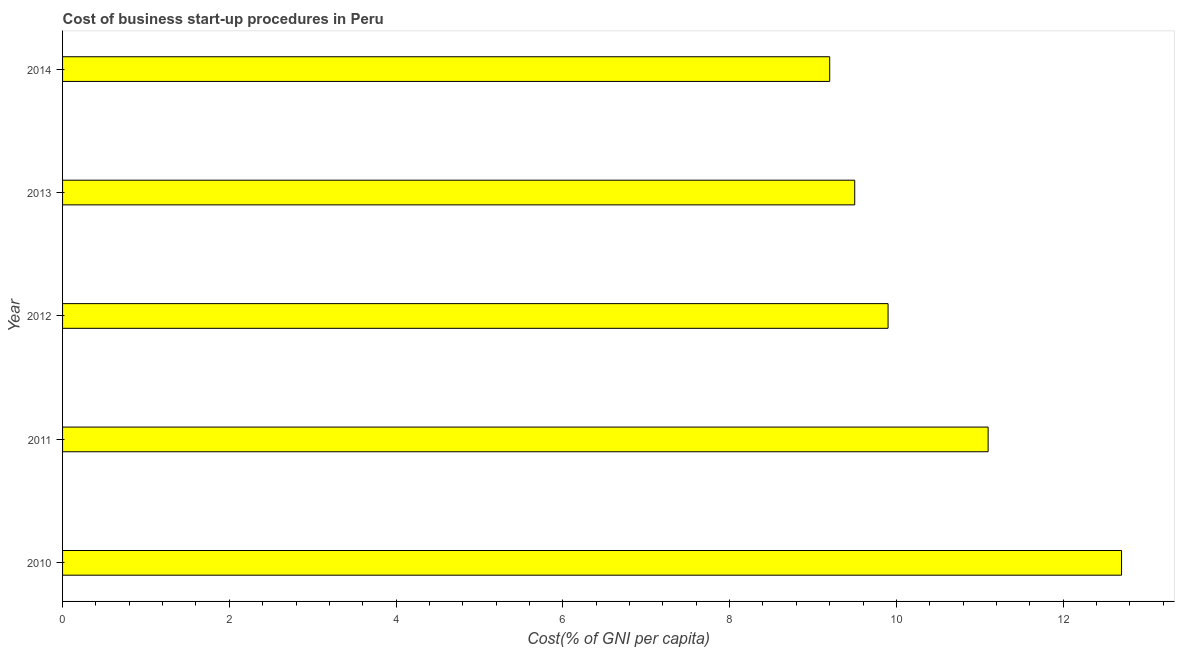Does the graph contain any zero values?
Provide a short and direct response. No. What is the title of the graph?
Your answer should be compact. Cost of business start-up procedures in Peru. What is the label or title of the X-axis?
Offer a very short reply. Cost(% of GNI per capita). What is the label or title of the Y-axis?
Offer a terse response. Year. What is the cost of business startup procedures in 2013?
Provide a short and direct response. 9.5. Across all years, what is the maximum cost of business startup procedures?
Provide a succinct answer. 12.7. What is the sum of the cost of business startup procedures?
Your response must be concise. 52.4. What is the average cost of business startup procedures per year?
Offer a terse response. 10.48. In how many years, is the cost of business startup procedures greater than 9.2 %?
Ensure brevity in your answer.  4. Do a majority of the years between 2011 and 2012 (inclusive) have cost of business startup procedures greater than 3.2 %?
Ensure brevity in your answer.  Yes. What is the ratio of the cost of business startup procedures in 2012 to that in 2014?
Offer a very short reply. 1.08. Is the cost of business startup procedures in 2010 less than that in 2014?
Your answer should be compact. No. Are the values on the major ticks of X-axis written in scientific E-notation?
Your answer should be compact. No. What is the Cost(% of GNI per capita) of 2012?
Make the answer very short. 9.9. What is the Cost(% of GNI per capita) of 2014?
Make the answer very short. 9.2. What is the difference between the Cost(% of GNI per capita) in 2010 and 2012?
Give a very brief answer. 2.8. What is the difference between the Cost(% of GNI per capita) in 2011 and 2012?
Give a very brief answer. 1.2. What is the difference between the Cost(% of GNI per capita) in 2011 and 2013?
Your answer should be very brief. 1.6. What is the difference between the Cost(% of GNI per capita) in 2011 and 2014?
Offer a very short reply. 1.9. What is the difference between the Cost(% of GNI per capita) in 2013 and 2014?
Make the answer very short. 0.3. What is the ratio of the Cost(% of GNI per capita) in 2010 to that in 2011?
Provide a succinct answer. 1.14. What is the ratio of the Cost(% of GNI per capita) in 2010 to that in 2012?
Offer a terse response. 1.28. What is the ratio of the Cost(% of GNI per capita) in 2010 to that in 2013?
Give a very brief answer. 1.34. What is the ratio of the Cost(% of GNI per capita) in 2010 to that in 2014?
Give a very brief answer. 1.38. What is the ratio of the Cost(% of GNI per capita) in 2011 to that in 2012?
Give a very brief answer. 1.12. What is the ratio of the Cost(% of GNI per capita) in 2011 to that in 2013?
Provide a succinct answer. 1.17. What is the ratio of the Cost(% of GNI per capita) in 2011 to that in 2014?
Your answer should be very brief. 1.21. What is the ratio of the Cost(% of GNI per capita) in 2012 to that in 2013?
Offer a very short reply. 1.04. What is the ratio of the Cost(% of GNI per capita) in 2012 to that in 2014?
Offer a terse response. 1.08. What is the ratio of the Cost(% of GNI per capita) in 2013 to that in 2014?
Give a very brief answer. 1.03. 